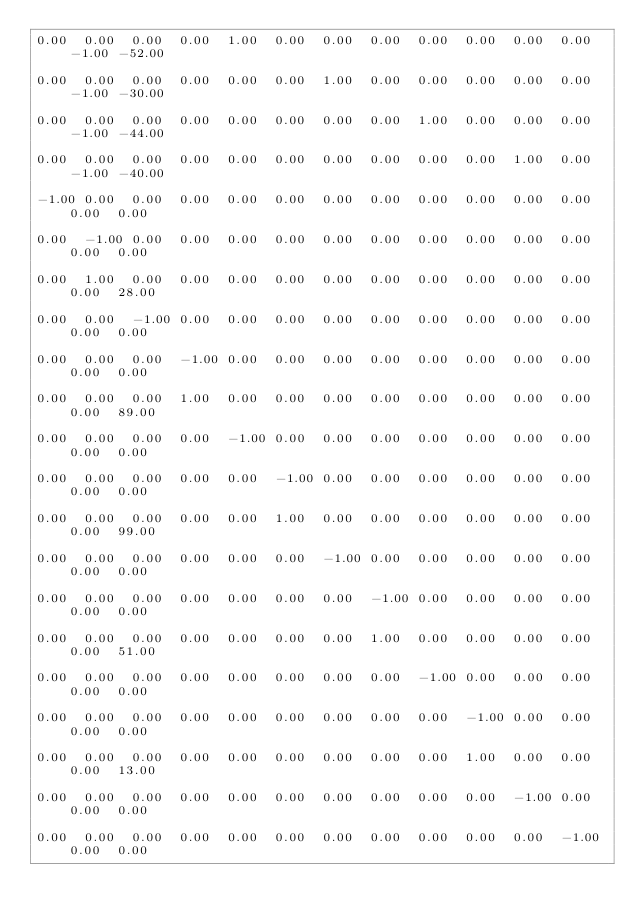<code> <loc_0><loc_0><loc_500><loc_500><_Matlab_>0.00	0.00	0.00	0.00	1.00	0.00	0.00	0.00	0.00	0.00	0.00	0.00	-1.00	-52.00

0.00	0.00	0.00	0.00	0.00	0.00	1.00	0.00	0.00	0.00	0.00	0.00	-1.00	-30.00

0.00	0.00	0.00	0.00	0.00	0.00	0.00	0.00	1.00	0.00	0.00	0.00	-1.00	-44.00

0.00	0.00	0.00	0.00	0.00	0.00	0.00	0.00	0.00	0.00	1.00	0.00	-1.00	-40.00

-1.00	0.00	0.00	0.00	0.00	0.00	0.00	0.00	0.00	0.00	0.00	0.00	0.00	0.00

0.00	-1.00	0.00	0.00	0.00	0.00	0.00	0.00	0.00	0.00	0.00	0.00	0.00	0.00

0.00	1.00	0.00	0.00	0.00	0.00	0.00	0.00	0.00	0.00	0.00	0.00	0.00	28.00

0.00	0.00	-1.00	0.00	0.00	0.00	0.00	0.00	0.00	0.00	0.00	0.00	0.00	0.00

0.00	0.00	0.00	-1.00	0.00	0.00	0.00	0.00	0.00	0.00	0.00	0.00	0.00	0.00

0.00	0.00	0.00	1.00	0.00	0.00	0.00	0.00	0.00	0.00	0.00	0.00	0.00	89.00

0.00	0.00	0.00	0.00	-1.00	0.00	0.00	0.00	0.00	0.00	0.00	0.00	0.00	0.00

0.00	0.00	0.00	0.00	0.00	-1.00	0.00	0.00	0.00	0.00	0.00	0.00	0.00	0.00

0.00	0.00	0.00	0.00	0.00	1.00	0.00	0.00	0.00	0.00	0.00	0.00	0.00	99.00

0.00	0.00	0.00	0.00	0.00	0.00	-1.00	0.00	0.00	0.00	0.00	0.00	0.00	0.00

0.00	0.00	0.00	0.00	0.00	0.00	0.00	-1.00	0.00	0.00	0.00	0.00	0.00	0.00

0.00	0.00	0.00	0.00	0.00	0.00	0.00	1.00	0.00	0.00	0.00	0.00	0.00	51.00

0.00	0.00	0.00	0.00	0.00	0.00	0.00	0.00	-1.00	0.00	0.00	0.00	0.00	0.00

0.00	0.00	0.00	0.00	0.00	0.00	0.00	0.00	0.00	-1.00	0.00	0.00	0.00	0.00

0.00	0.00	0.00	0.00	0.00	0.00	0.00	0.00	0.00	1.00	0.00	0.00	0.00	13.00

0.00	0.00	0.00	0.00	0.00	0.00	0.00	0.00	0.00	0.00	-1.00	0.00	0.00	0.00

0.00	0.00	0.00	0.00	0.00	0.00	0.00	0.00	0.00	0.00	0.00	-1.00	0.00	0.00
</code> 